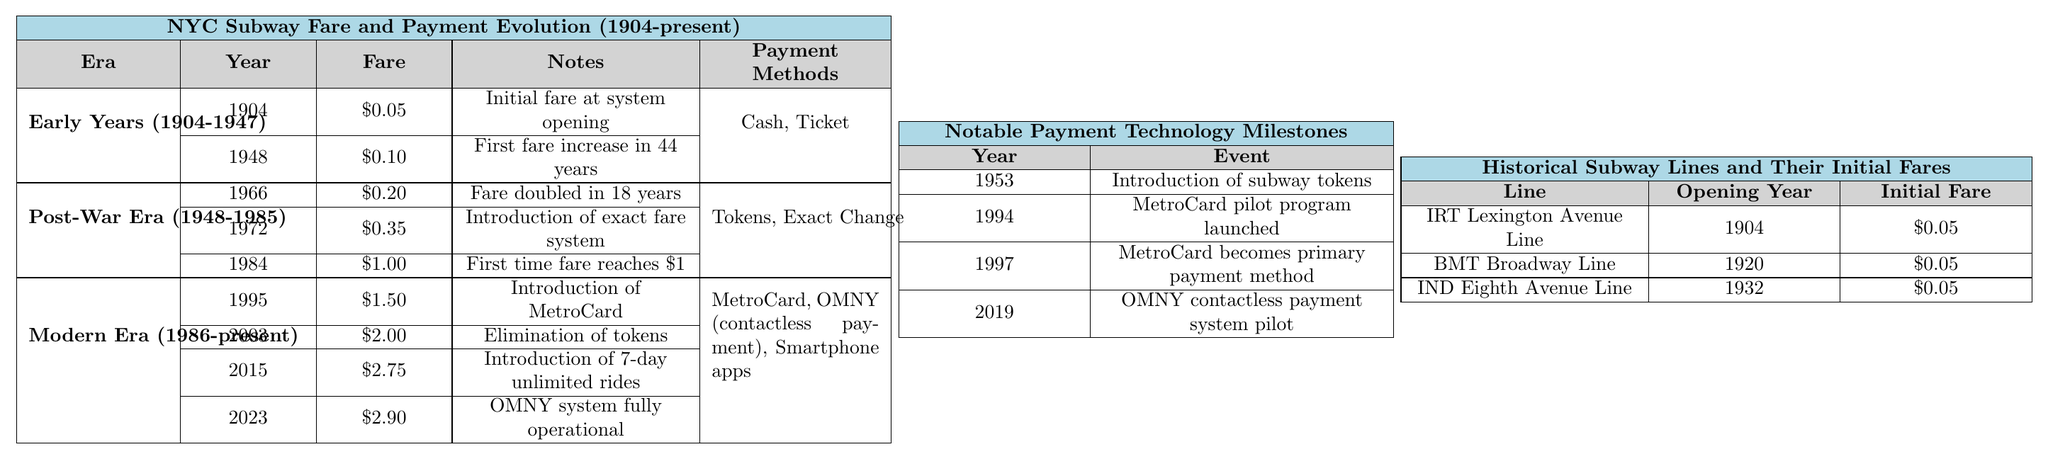What was the fare in 1904? Referring to the table, under the "Early Years (1904-1947)" era, the fare for the year 1904 is listed as $0.05.
Answer: $0.05 How much did the fare increase from 1948 to 1984? The fare in 1948 was $0.10 and in 1984 it increased to $1.00. Calculating the difference: $1.00 - $0.10 = $0.90.
Answer: $0.90 Did the fare ever drop from its initial value of $0.05? The initial fare of $0.05 was consistent until 1948, and there were no instances of it decreasing in the table. Thus, the answer is no.
Answer: No What payment methods were available during the Modern Era (1986-present)? Checking the "Modern Era" section, the payment methods listed are MetroCard, OMNY (contactless payment), and Smartphone apps.
Answer: MetroCard, OMNY, Smartphone apps What was the fare for the first fare increase after 1904 and what year was it? The first fare increase after 1904 happened in 1948 when the fare rose to $0.10.
Answer: $0.10 in 1948 How many eras had a fare of $0.05? Looking in the table, four fares listed at $0.05 occurred in 1904, and with two more occurrences (IRT Lexington Avenue Line, BMT Broadway Line, and IND Eighth Avenue Line), there are a total of three entries, all in the Early Years.
Answer: Three eras had $0.05 What was the average fare from the beginning until 2023? The fares listed from 1904 to 2023 are $0.05, $0.10, $0.20, $0.35, $1.00, $1.50, $2.00, $2.75, and $2.90. The sum of these fares is $10.80, with 9 values to average, thus $10.80/9 = $1.20.
Answer: $1.20 What major payment technology was introduced in 1997? The table specifies that in 1997, the MetroCard became the primary payment method, indicating a major technological advancement in subway payment options.
Answer: MetroCard became primary method What is the fare difference between 1984 and 2023? The fare in 1984 was $1.00, and in 2023 it is $2.90. Calculating the difference: $2.90 - $1.00 = $1.90.
Answer: $1.90 